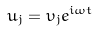Convert formula to latex. <formula><loc_0><loc_0><loc_500><loc_500>u _ { j } = \upsilon _ { j } e ^ { i \omega t }</formula> 